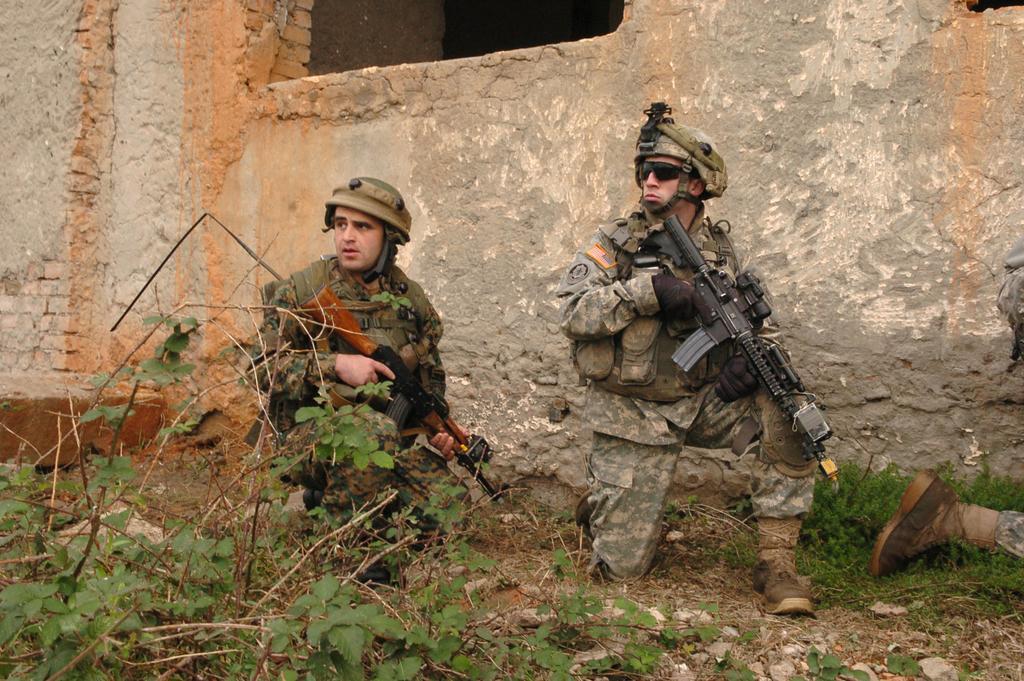In one or two sentences, can you explain what this image depicts? In this picture we can see few people, they wore helmets and they are holding guns, beside to them we can find few plants and a wall. 